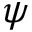Convert formula to latex. <formula><loc_0><loc_0><loc_500><loc_500>\psi</formula> 